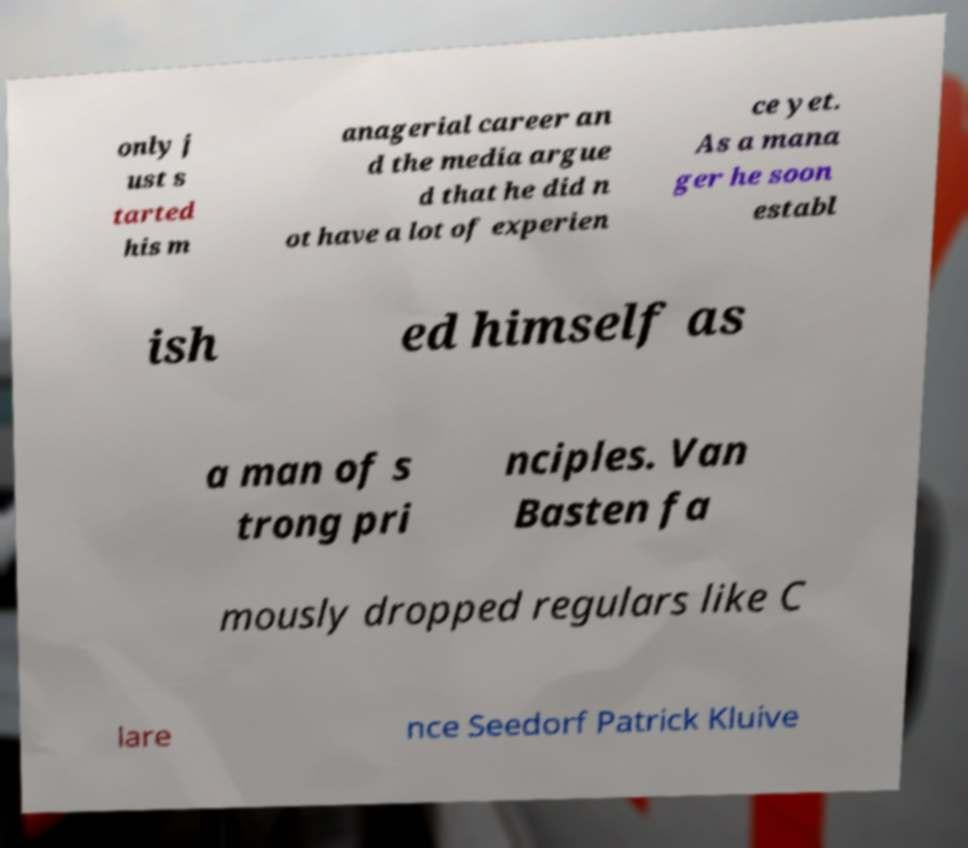There's text embedded in this image that I need extracted. Can you transcribe it verbatim? only j ust s tarted his m anagerial career an d the media argue d that he did n ot have a lot of experien ce yet. As a mana ger he soon establ ish ed himself as a man of s trong pri nciples. Van Basten fa mously dropped regulars like C lare nce Seedorf Patrick Kluive 